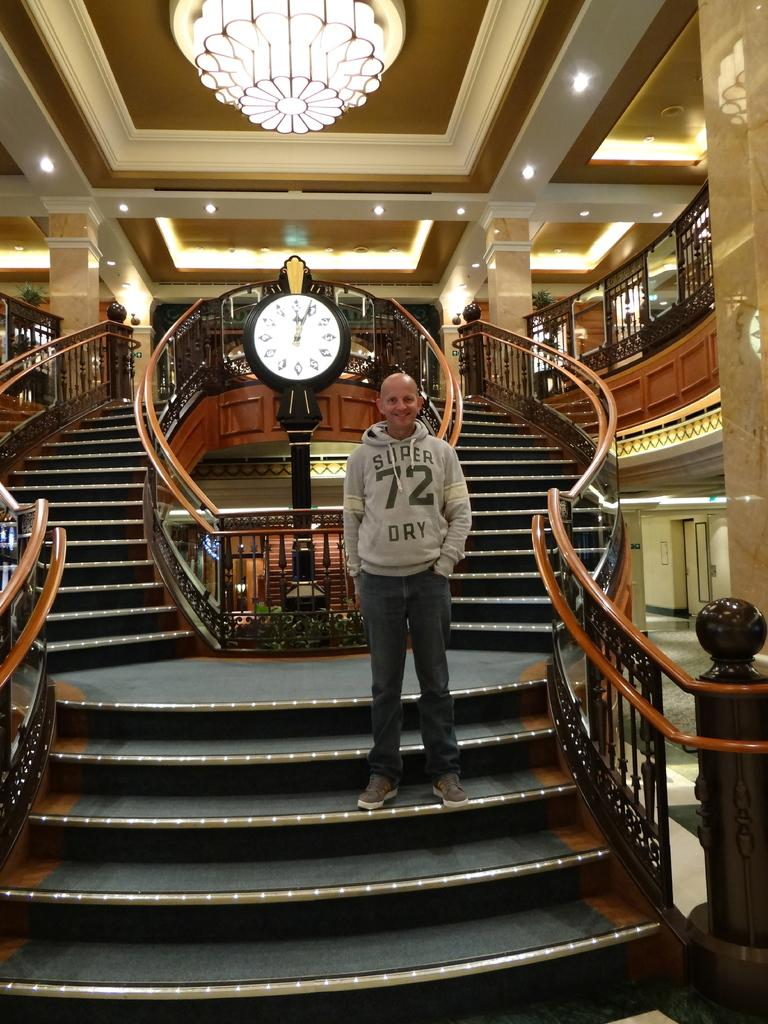<image>
Relay a brief, clear account of the picture shown. Gentleman standing on the grand staircase wearing a super 72 dry 